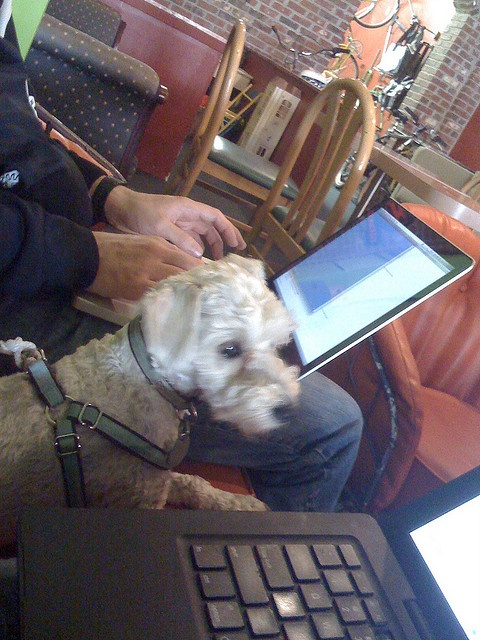Describe the objects in this image and their specific colors. I can see keyboard in navy, black, gray, and purple tones, people in lightgray, black, navy, and gray tones, dog in navy, gray, black, darkgray, and lightgray tones, laptop in navy, black, gray, and purple tones, and chair in navy, brown, and purple tones in this image. 